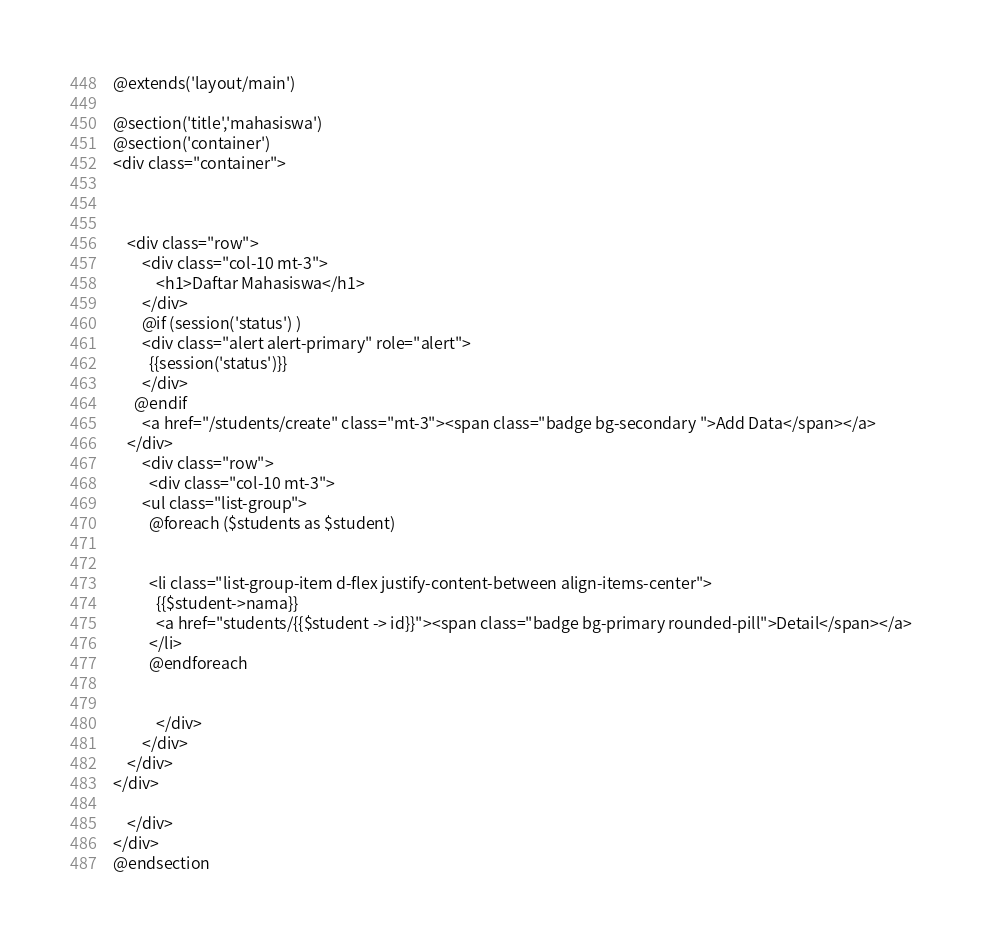Convert code to text. <code><loc_0><loc_0><loc_500><loc_500><_PHP_>@extends('layout/main')

@section('title','mahasiswa')
@section('container')
<div class="container">



    <div class="row">
        <div class="col-10 mt-3">
            <h1>Daftar Mahasiswa</h1>
        </div>
        @if (session('status') )
        <div class="alert alert-primary" role="alert">
          {{session('status')}}
        </div>
      @endif
        <a href="/students/create" class="mt-3"><span class="badge bg-secondary ">Add Data</span></a>
    </div>
        <div class="row">
          <div class="col-10 mt-3">
        <ul class="list-group">
          @foreach ($students as $student)
              
         
          <li class="list-group-item d-flex justify-content-between align-items-center">
            {{$student->nama}}
            <a href="students/{{$student -> id}}"><span class="badge bg-primary rounded-pill">Detail</span></a>
          </li>
          @endforeach


            </div>
        </div>
    </div>
</div>
        
    </div>
</div>
@endsection

</code> 